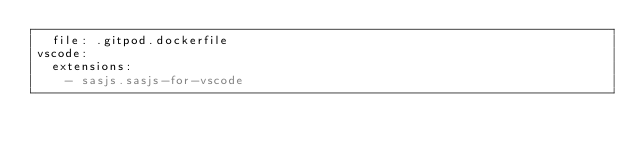<code> <loc_0><loc_0><loc_500><loc_500><_YAML_>  file: .gitpod.dockerfile
vscode:
  extensions:
    - sasjs.sasjs-for-vscode
</code> 